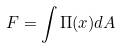<formula> <loc_0><loc_0><loc_500><loc_500>F = \int \Pi ( x ) d A</formula> 